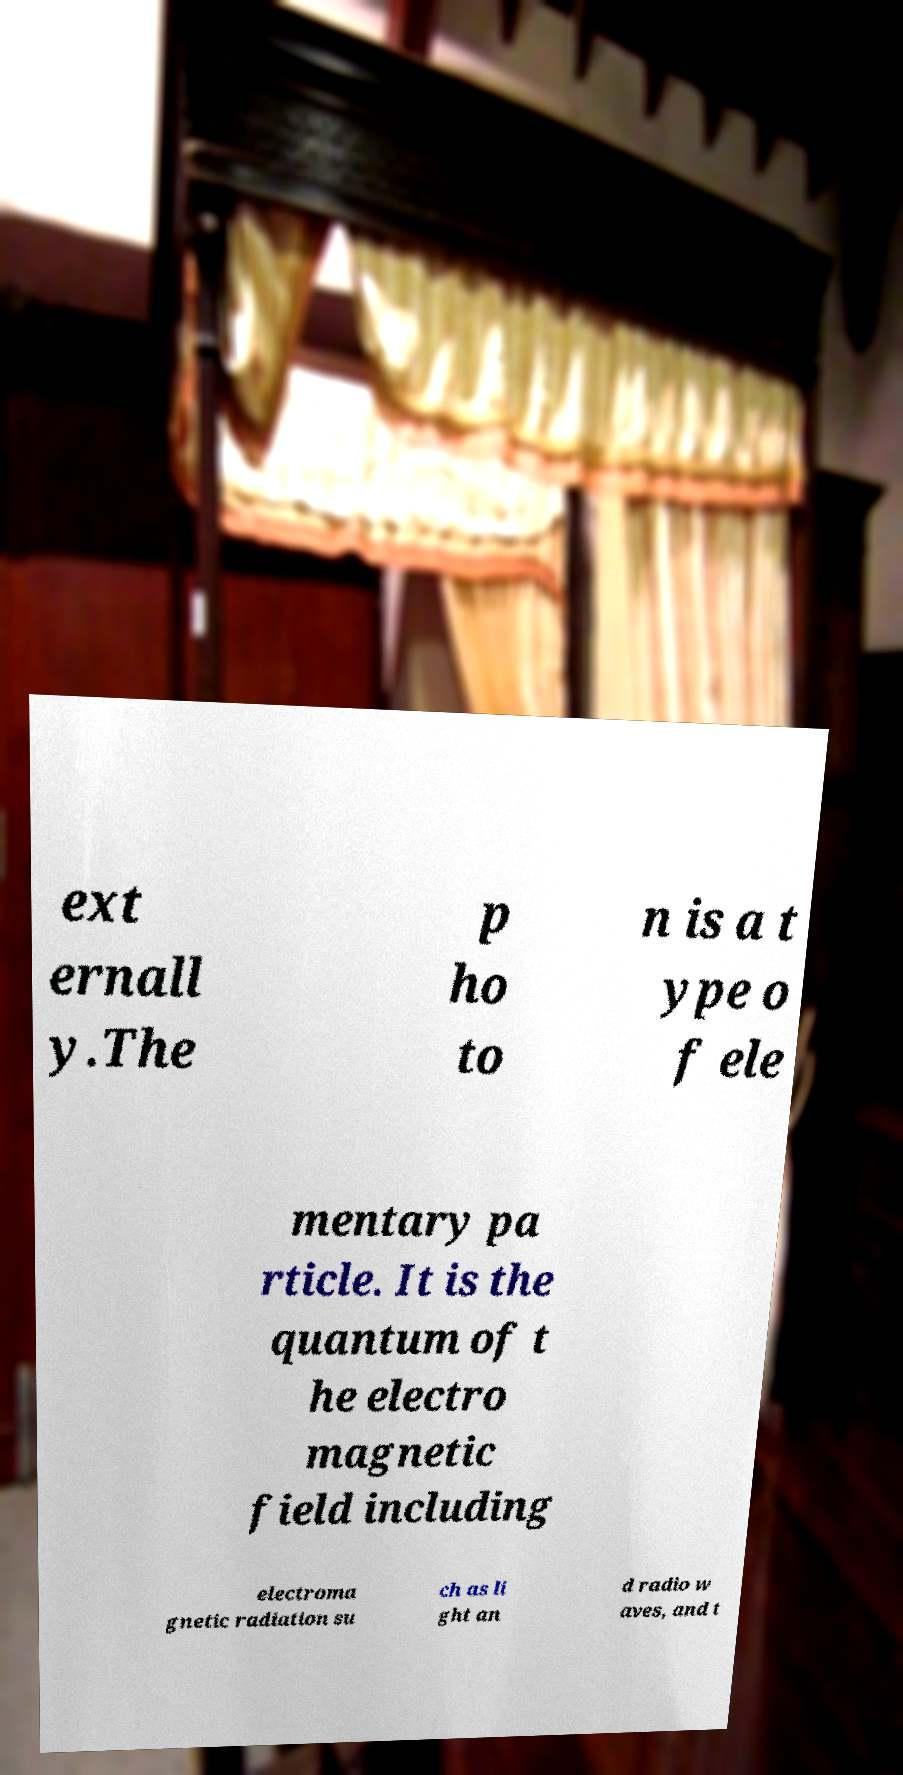I need the written content from this picture converted into text. Can you do that? ext ernall y.The p ho to n is a t ype o f ele mentary pa rticle. It is the quantum of t he electro magnetic field including electroma gnetic radiation su ch as li ght an d radio w aves, and t 